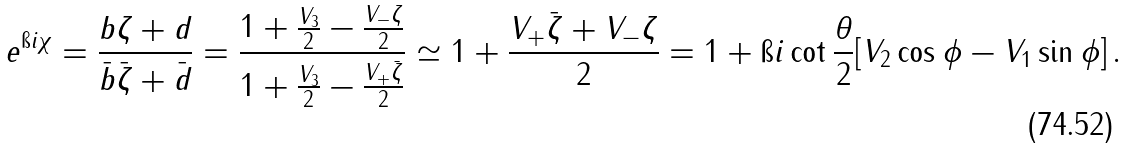<formula> <loc_0><loc_0><loc_500><loc_500>e ^ { \i i \chi } = \frac { b \zeta + d } { \bar { b } \bar { \zeta } + \bar { d } } = \frac { 1 + \frac { V _ { 3 } } { 2 } - \frac { V _ { - } \zeta } { 2 } } { 1 + \frac { V _ { 3 } } { 2 } - \frac { V _ { + } \bar { \zeta } } { 2 } } \simeq 1 + \frac { V _ { + } \bar { \zeta } + V _ { - } \zeta } { 2 } = 1 + \i i \cot \frac { \theta } { 2 } [ V _ { 2 } \cos \phi - V _ { 1 } \sin \phi ] \, .</formula> 